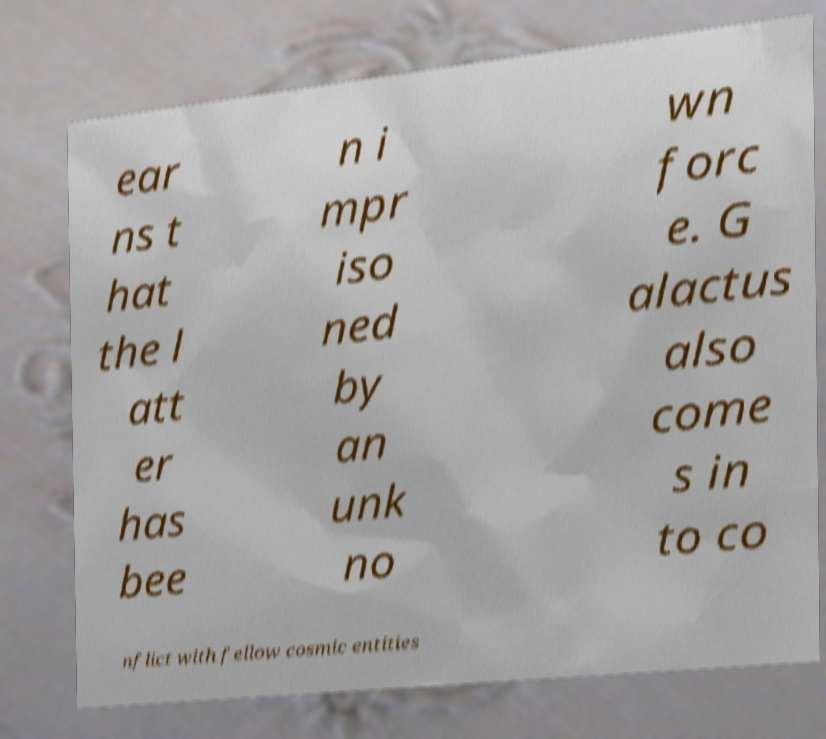Could you extract and type out the text from this image? ear ns t hat the l att er has bee n i mpr iso ned by an unk no wn forc e. G alactus also come s in to co nflict with fellow cosmic entities 